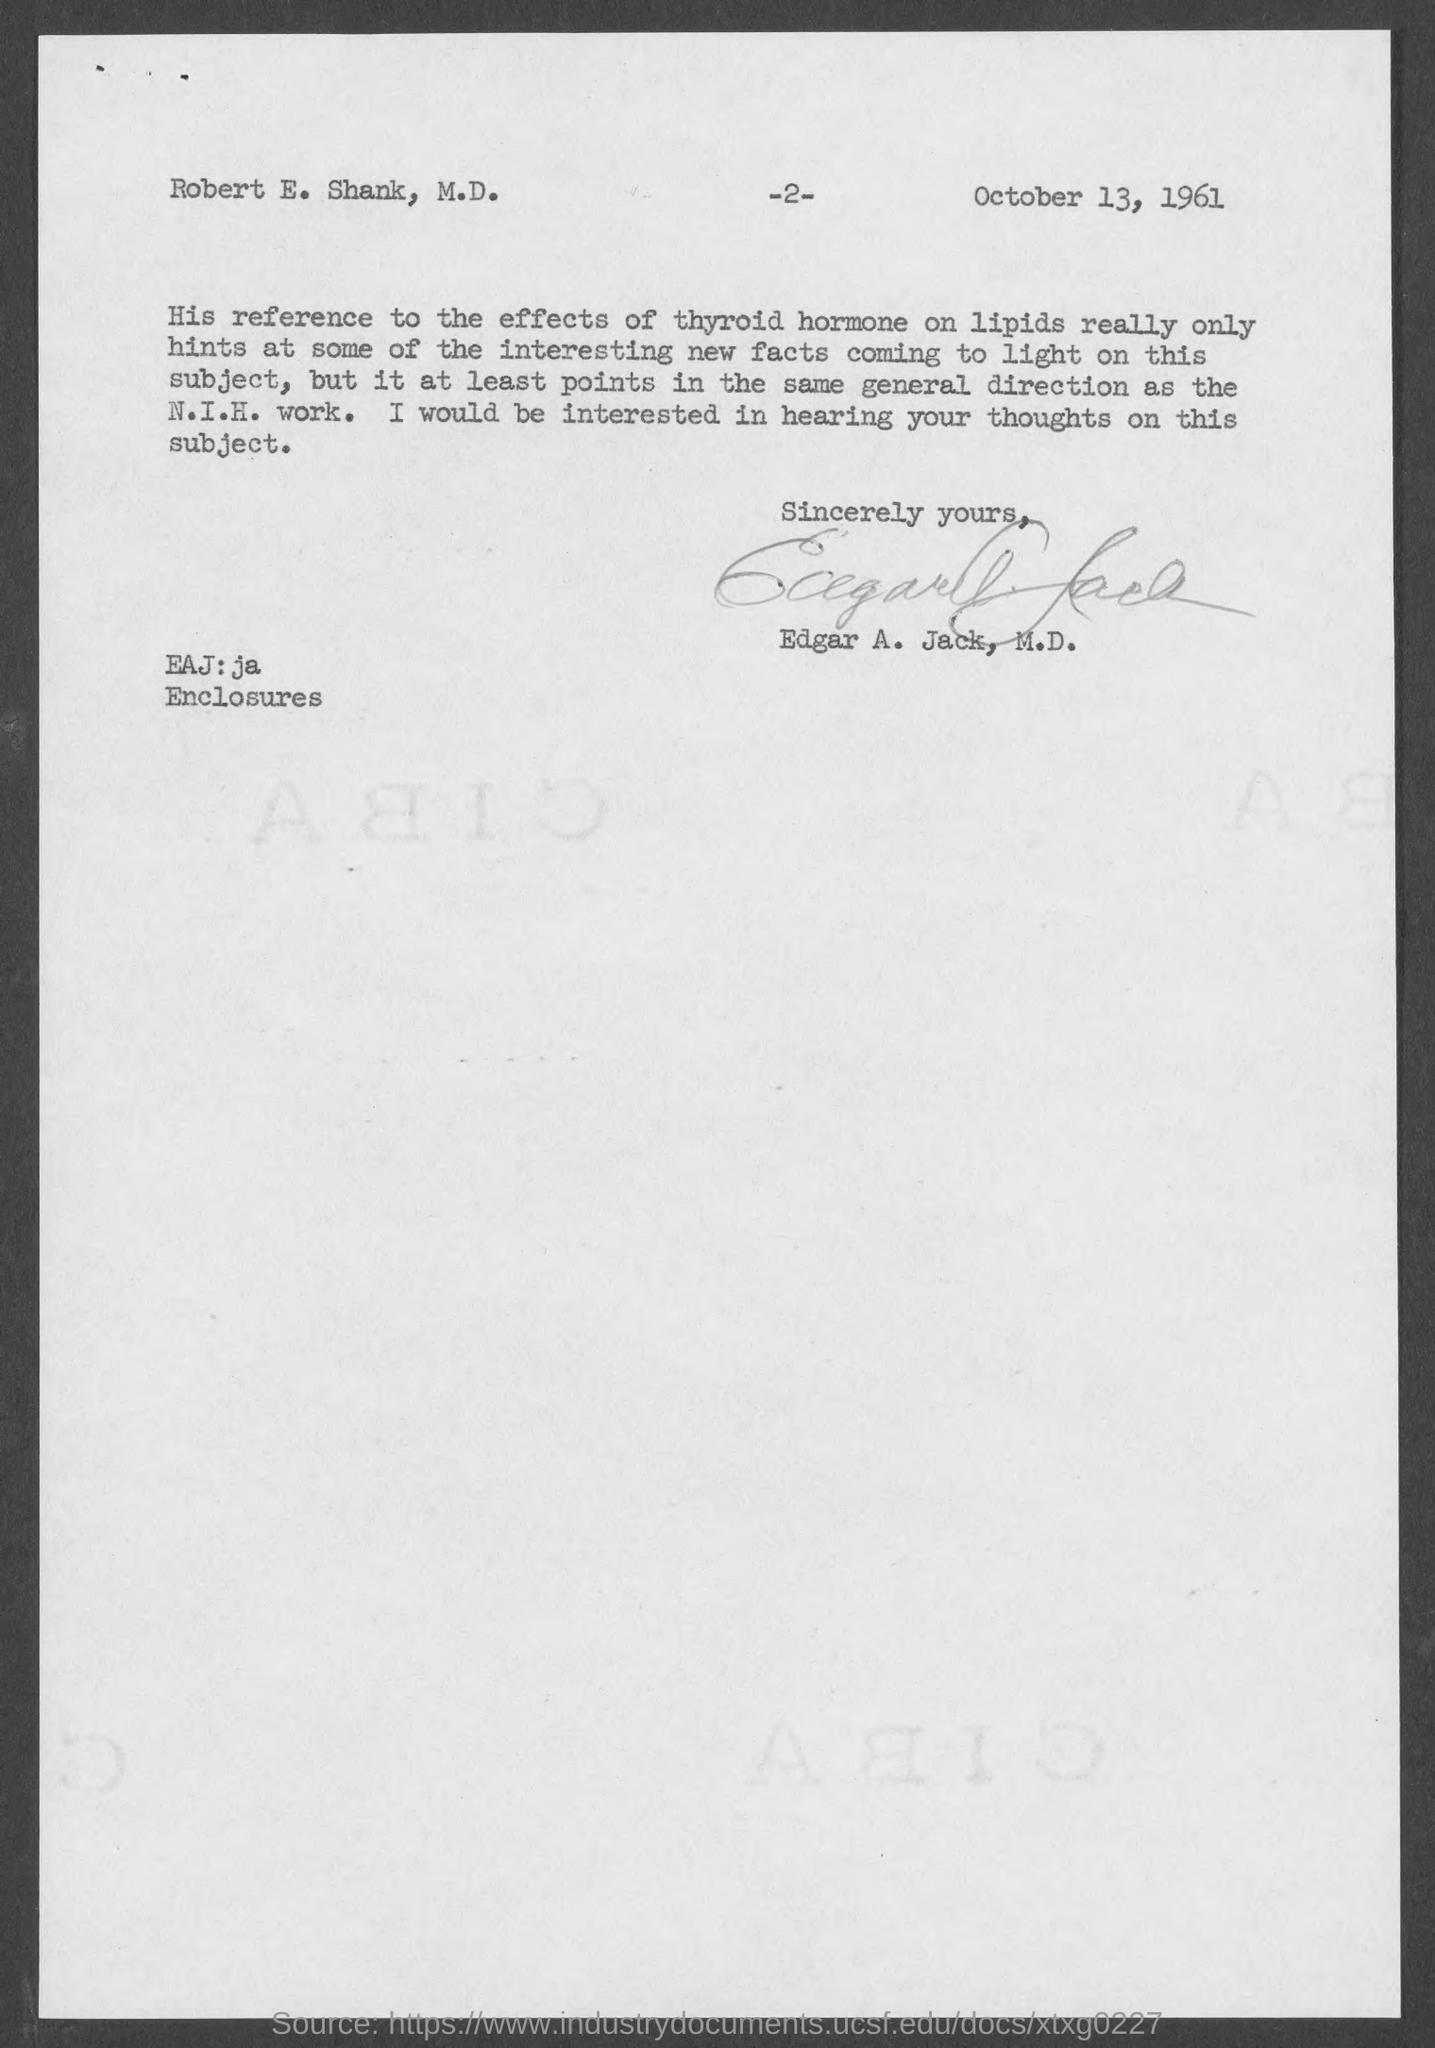Point out several critical features in this image. The author of the letter is identified as "Edgar A. Jack, M.D.". The page number at the top of the page is -2-. To whom this letter is written, Robert E. Shank is the recipient. The date mentioned in the document is October 13, 1961. 